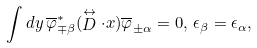Convert formula to latex. <formula><loc_0><loc_0><loc_500><loc_500>\int d y \, \overline { \varphi } ^ { * } _ { \mp \beta } ( \stackrel { \leftrightarrow } { D } \cdot { x } ) \overline { \varphi } _ { \pm \alpha } = 0 , \, \epsilon _ { \beta } = \epsilon _ { \alpha } ,</formula> 